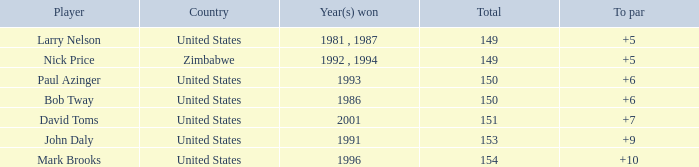What is Zimbabwe's total with a to par higher than 5? None. 